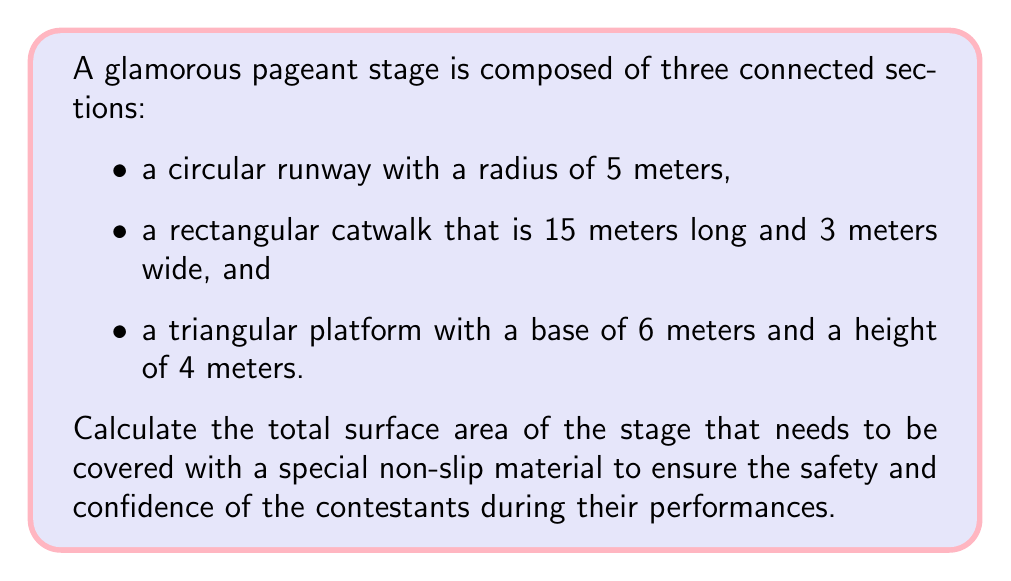Provide a solution to this math problem. To calculate the total surface area, we need to determine the area of each section and sum them up:

1. Circular runway:
   The area of a circle is given by $A = \pi r^2$
   $A_circle = \pi (5m)^2 = 25\pi m^2$

2. Rectangular catwalk:
   The area of a rectangle is given by $A = l \times w$
   $A_rectangle = 15m \times 3m = 45m^2$

3. Triangular platform:
   The area of a triangle is given by $A = \frac{1}{2} \times base \times height$
   $A_triangle = \frac{1}{2} \times 6m \times 4m = 12m^2$

Total surface area:
$$\begin{aligned}
A_{total} &= A_{circle} + A_{rectangle} + A_{triangle} \\
&= 25\pi m^2 + 45m^2 + 12m^2 \\
&= 25\pi m^2 + 57m^2 \\
&\approx 135.52m^2
\end{aligned}$$

[asy]
import geometry;

unitsize(10mm);

// Circular runway
draw(circle((0,0),5), blue);

// Rectangular catwalk
fill(box((-1.5,-7.5),(1.5,-22.5)), green);

// Triangular platform
fill((-3,-25)--(3,-25)--(0,-29)--cycle, red);

label("5m", (2.5,0), E);
label("15m", (1.5,-15), E);
label("3m", (0,-7.5), N);
label("6m", (0,-25), S);
label("4m", (-1.5,-27), W);

[/asy]
Answer: $135.52m^2$ 